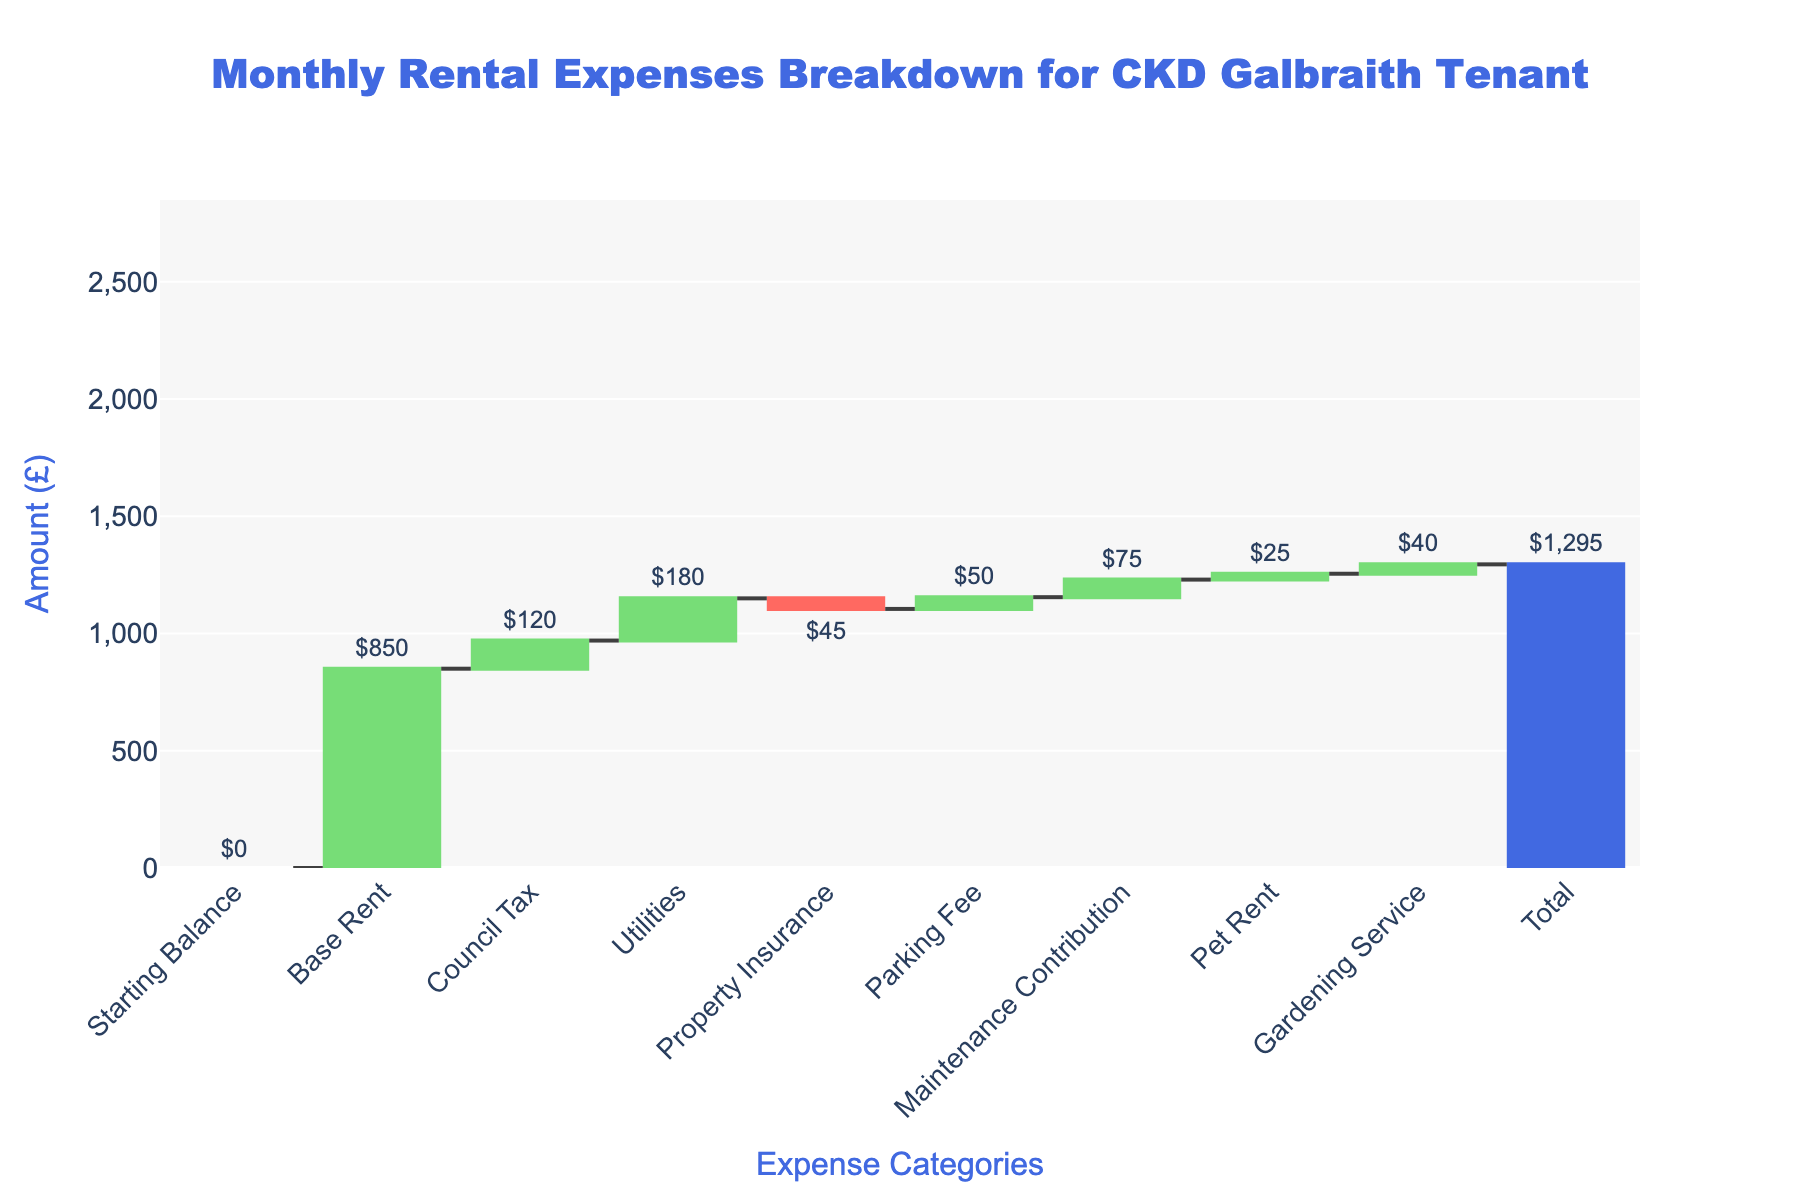Which expense category has the highest amount? The tallest segment on the waterfall chart represents the highest amount. Here, it is the "Base Rent".
Answer: Base Rent What is the total monthly rental expense? The final value on the waterfall chart, marked in a distinct color, shows the total monthly rental expense. It is £1,295.
Answer: £1,295 How much is spent on Council Tax monthly? Locate the segment labeled "Council Tax" on the chart and refer to its value displayed on top. It indicates £120.
Answer: £120 Which expense category reduces the total expense? The category with a negative value reduces the total expense. Here, "Property Insurance" shows a negative amount of -£45.
Answer: Property Insurance How much do 'Utilities' and 'Council Tax' add up to monthly? Sum the amounts for "Council Tax" (£120) and "Utilities" (£180). The total is £120 + £180 = £300.
Answer: £300 Is the amount spent on Gardening Service higher or lower than Maintenance Contribution? Compare the two segments labeled "Gardening Service" (£40) and "Maintenance Contribution" (£75). The amount for "Gardening Service" is lower.
Answer: Lower What's the difference between the highest expense and the lowest expense (excluding total)? The highest expense is "Base Rent" (£850) and the lowest expense is "Property Insurance" (-£45). The difference is £850 - (-£45) = £895.
Answer: £895 Does the "Parking Fee" contribute more or less to the total than "Pet Rent"? Compare the segments labeled "Parking Fee" (£50) and "Pet Rent" (£25). The "Parking Fee" contributes more.
Answer: More How many categories contribute positively to the total monthly rental expenses? Count the segments with positive values (excluding total). The categories are: Base Rent, Council Tax, Utilities, Parking Fee, Maintenance Contribution, Pet Rent, Gardening Service. There are 7 positive categories.
Answer: 7 What is the aggregated amount spent on additional services like Property Insurance, Parking Fee, Gardening Service, and Pet Rent? Sum the values of "Property Insurance" (-£45), "Parking Fee" (£50), "Gardening Service" (£40), and "Pet Rent" (£25). The total is -£45 + £50 + £40 + £25 = £70.
Answer: £70 